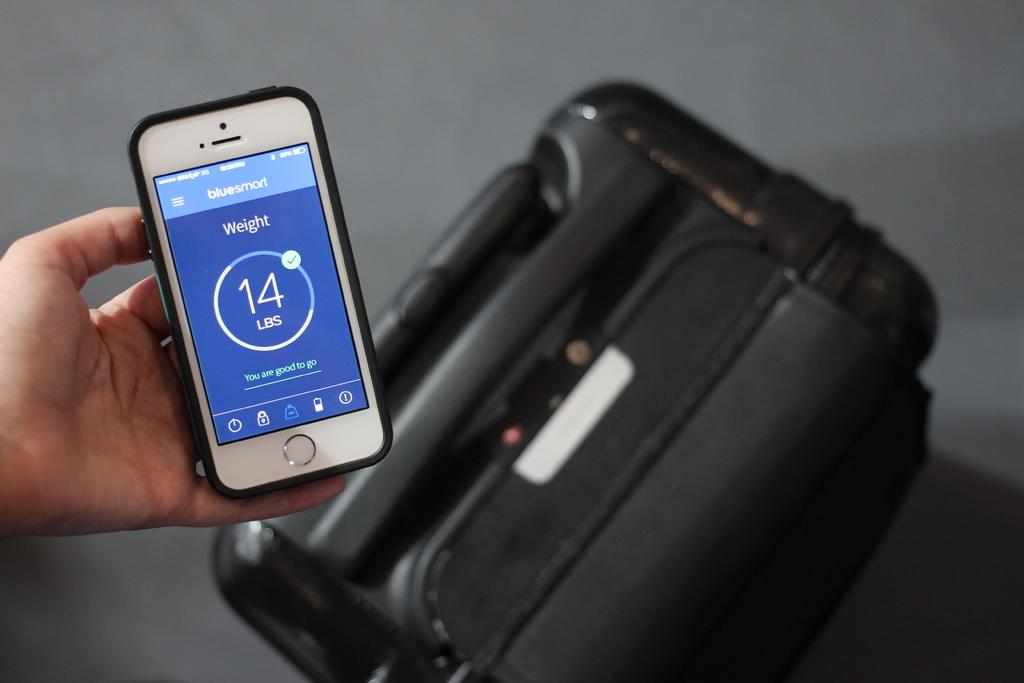Provide a one-sentence caption for the provided image. Iphone that shows a bluesmart app with a weight total on the screen. 